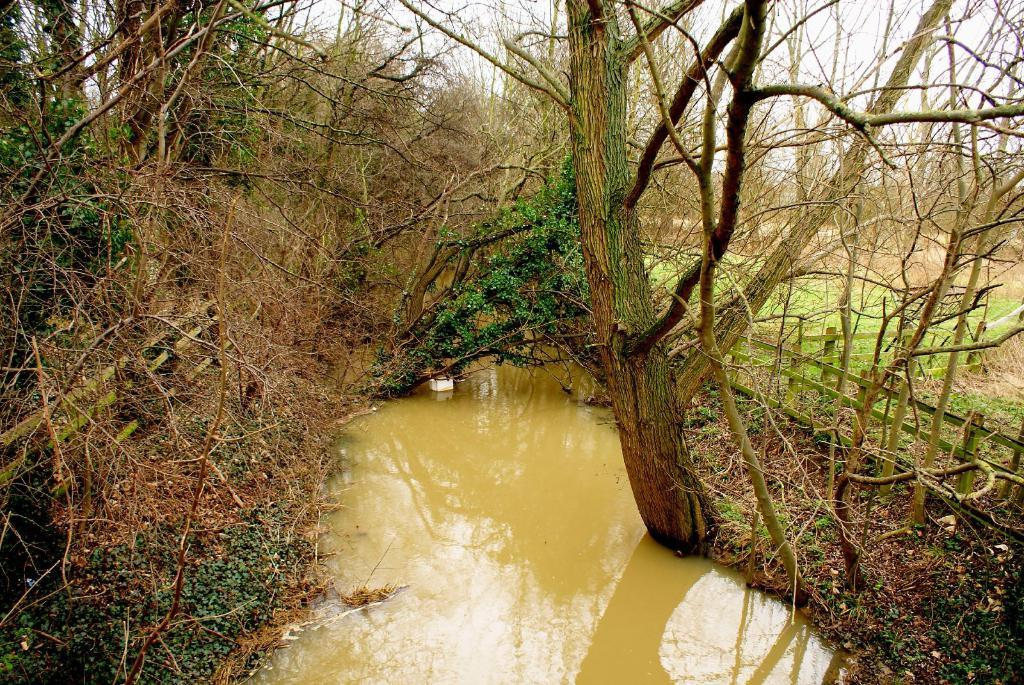What type of environment is depicted in the image? The image appears to be taken in a forest. What can be seen on the left side of the image? There are many trees on the left side of the image. What can be seen on the right side of the image? There are many trees on the right side of the image, and there is also a small wooden bridge. What is visible at the top of the image? The sky is visible at the top of the image. How many snakes can be seen crawling through the hole in the image? There are no snakes or holes present in the image; it depicts a forest with trees and a wooden bridge. 